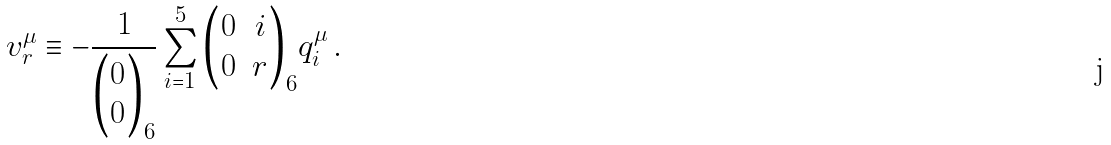<formula> <loc_0><loc_0><loc_500><loc_500>v _ { r } ^ { \mu } \equiv - \frac { 1 } { { \begin{pmatrix} 0 \\ 0 \end{pmatrix} } _ { 6 } } \sum _ { i = 1 } ^ { 5 } { { \begin{pmatrix} 0 & i \\ 0 & r \end{pmatrix} } _ { 6 } } q _ { i } ^ { \mu } \, .</formula> 